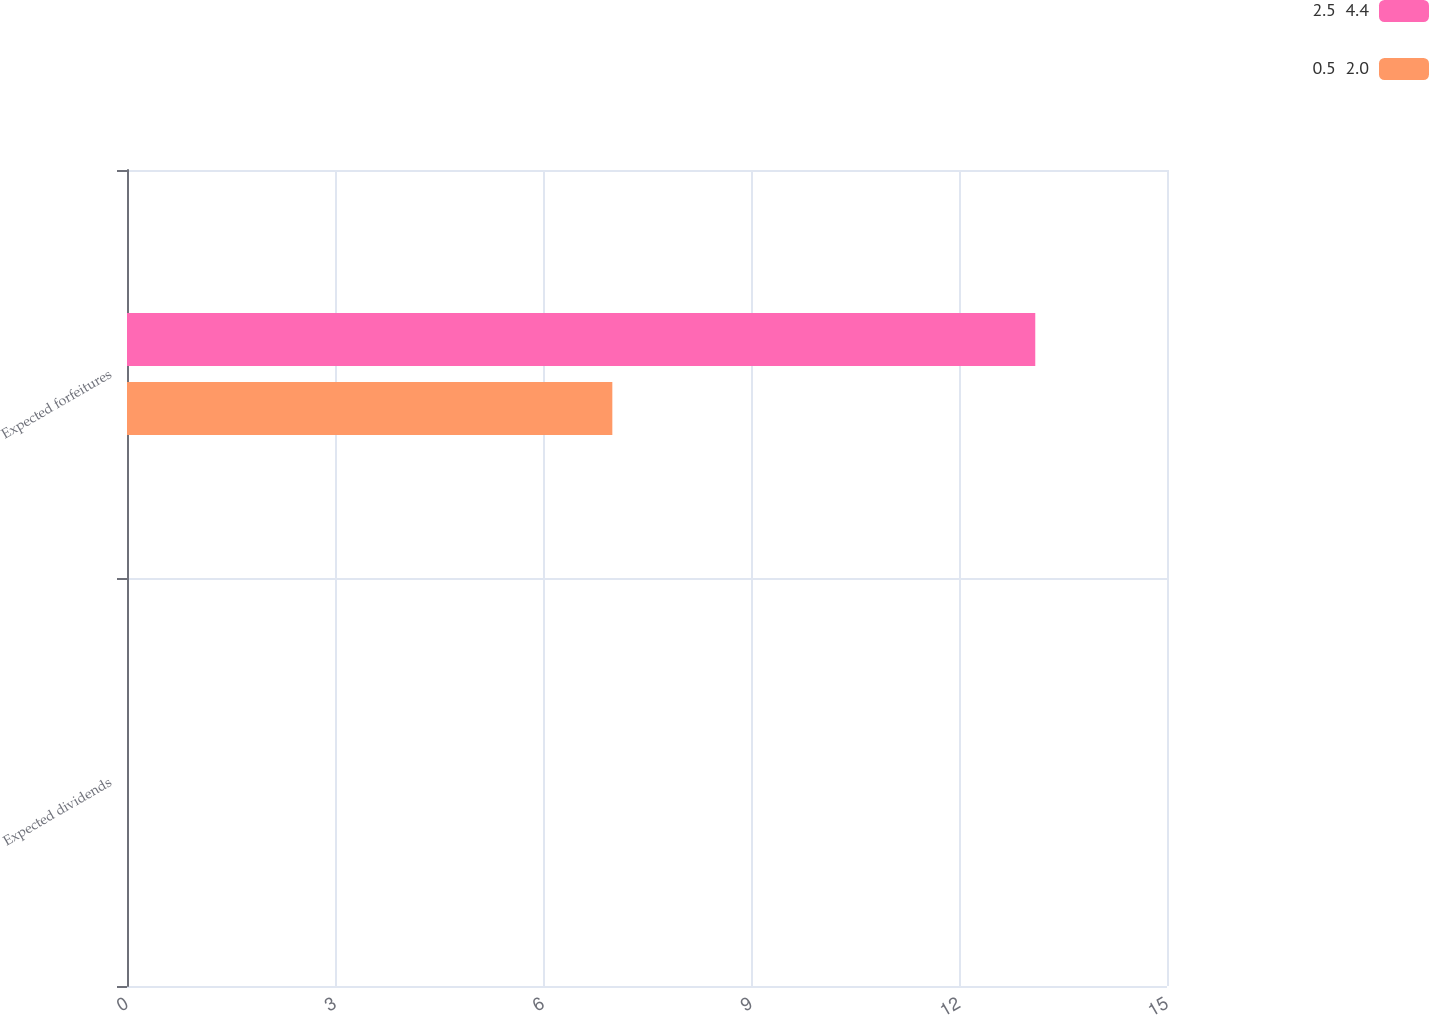Convert chart. <chart><loc_0><loc_0><loc_500><loc_500><stacked_bar_chart><ecel><fcel>Expected dividends<fcel>Expected forfeitures<nl><fcel>2.5  4.4<fcel>0<fcel>13.1<nl><fcel>0.5  2.0<fcel>0<fcel>7<nl></chart> 